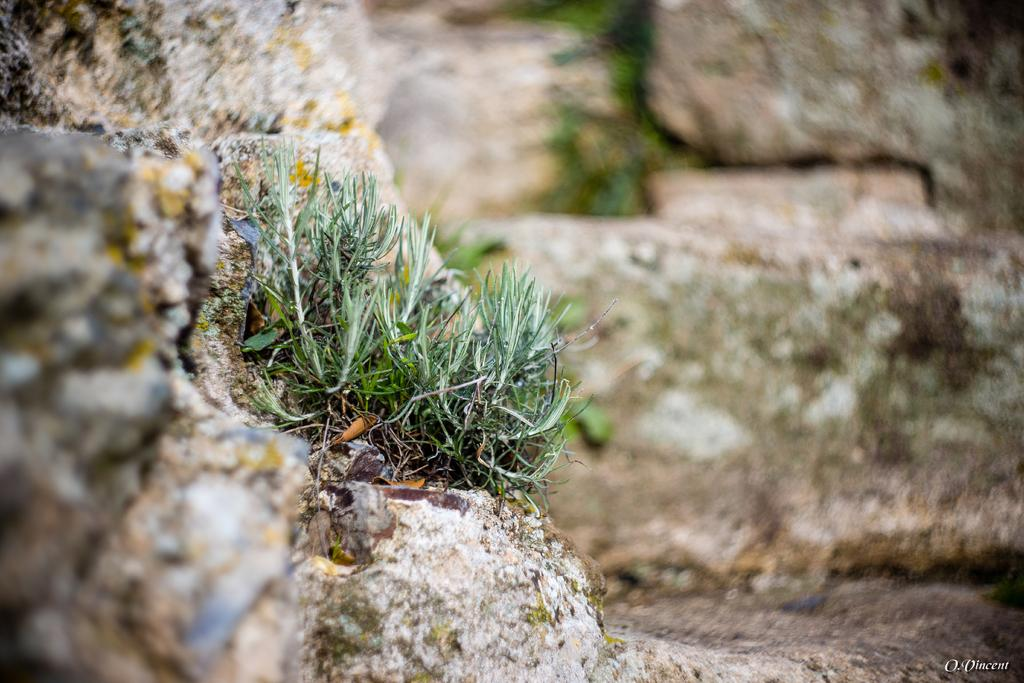What type of natural elements can be seen in the image? There are rocks and grass in the image. Can you describe the texture of the rocks in the image? The texture of the rocks cannot be determined from the image alone. What type of vegetation is present in the image? Grass is present in the image. Reasoning: Let's think step by step by step in order to produce the conversation. We start by identifying the main subjects in the image, which are the rocks and grass. Then, we formulate questions that focus on the characteristics of these subjects, ensuring that each question can be answered definitively with the information given. We avoid yes/no questions and ensure that the language is simple and clear. Absurd Question/Answer: What type of hair can be seen on the rocks in the image? There is no hair present on the rocks in the image. What type of shock can be seen in the image? There is no shock present in the image. What type of hair can be seen on the rocks in the image? There is no hair present on the rocks in the image. What type of shock can be seen in the image? There is no shock present in the image. 